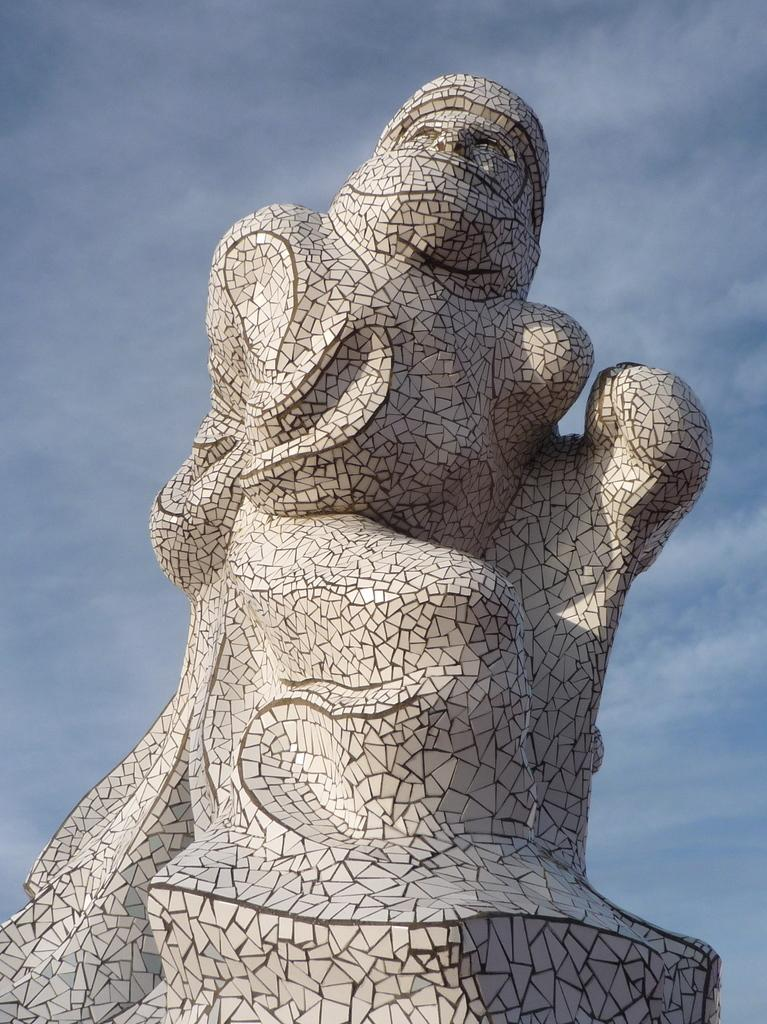What is the main subject of the image? There is a sculpture in the image. What can be seen behind the sculpture? The sky is visible behind the sculpture. What type of apparatus is being used to measure the sculpture's thoughts in the image? There is no apparatus or measurement of thoughts in the image; it only features a sculpture and the sky. 